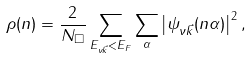Convert formula to latex. <formula><loc_0><loc_0><loc_500><loc_500>\rho ( n ) = \frac { 2 } { N _ { \Box } } \sum _ { E _ { \nu \vec { k } } < E _ { F } } \sum _ { \alpha } \left | \psi _ { \nu \vec { k } } ( n \alpha ) \right | ^ { 2 } ,</formula> 